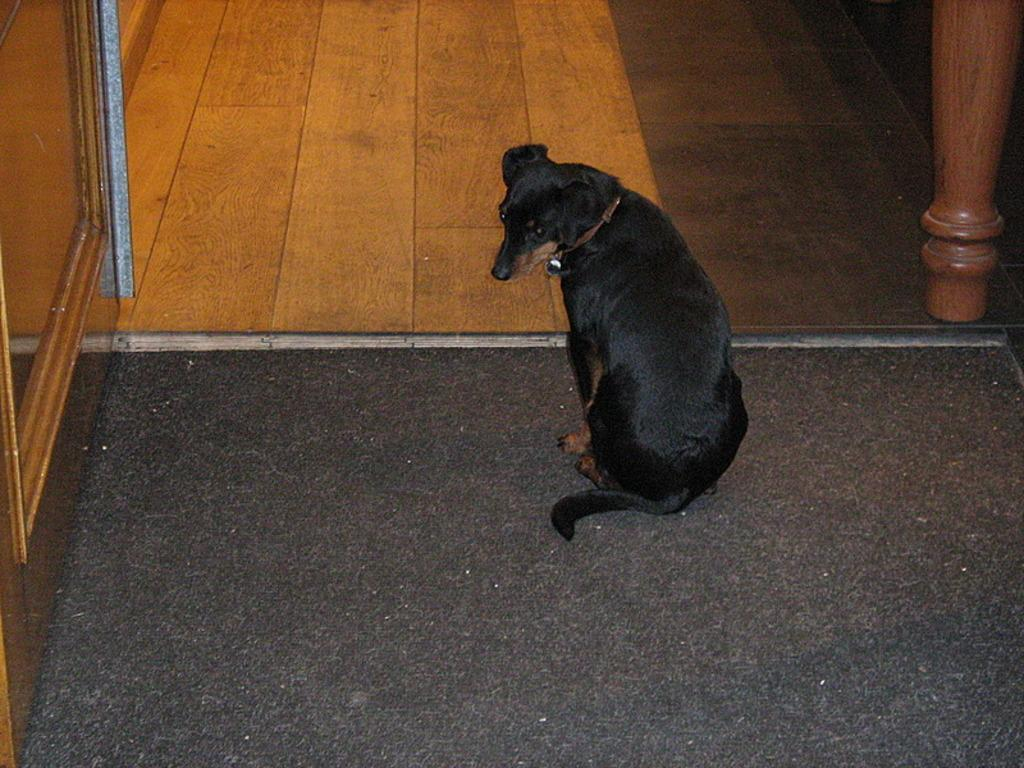What type of animal is in the image? There is a dog in the image. What color is the dog? The dog is black. What flavor of ice cream is the dog holding on the tray in the image? There is no ice cream or tray present in the image; it only features a black dog. 